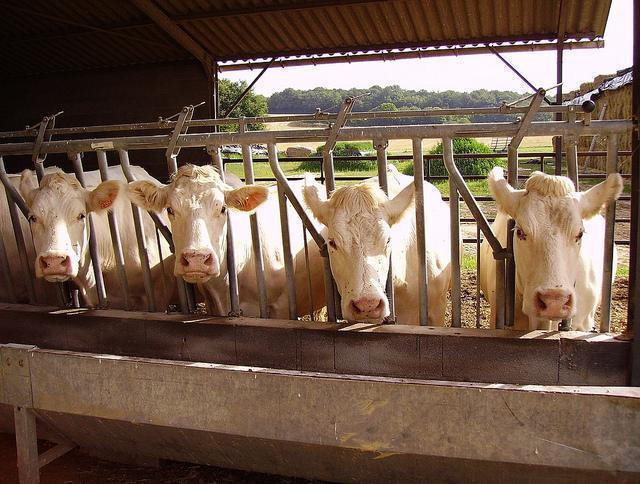Why are these cows held in place at the feeder?
Choose the right answer from the provided options to respond to the question.
Options: Butcher, milk, petting, helping. Milk. 